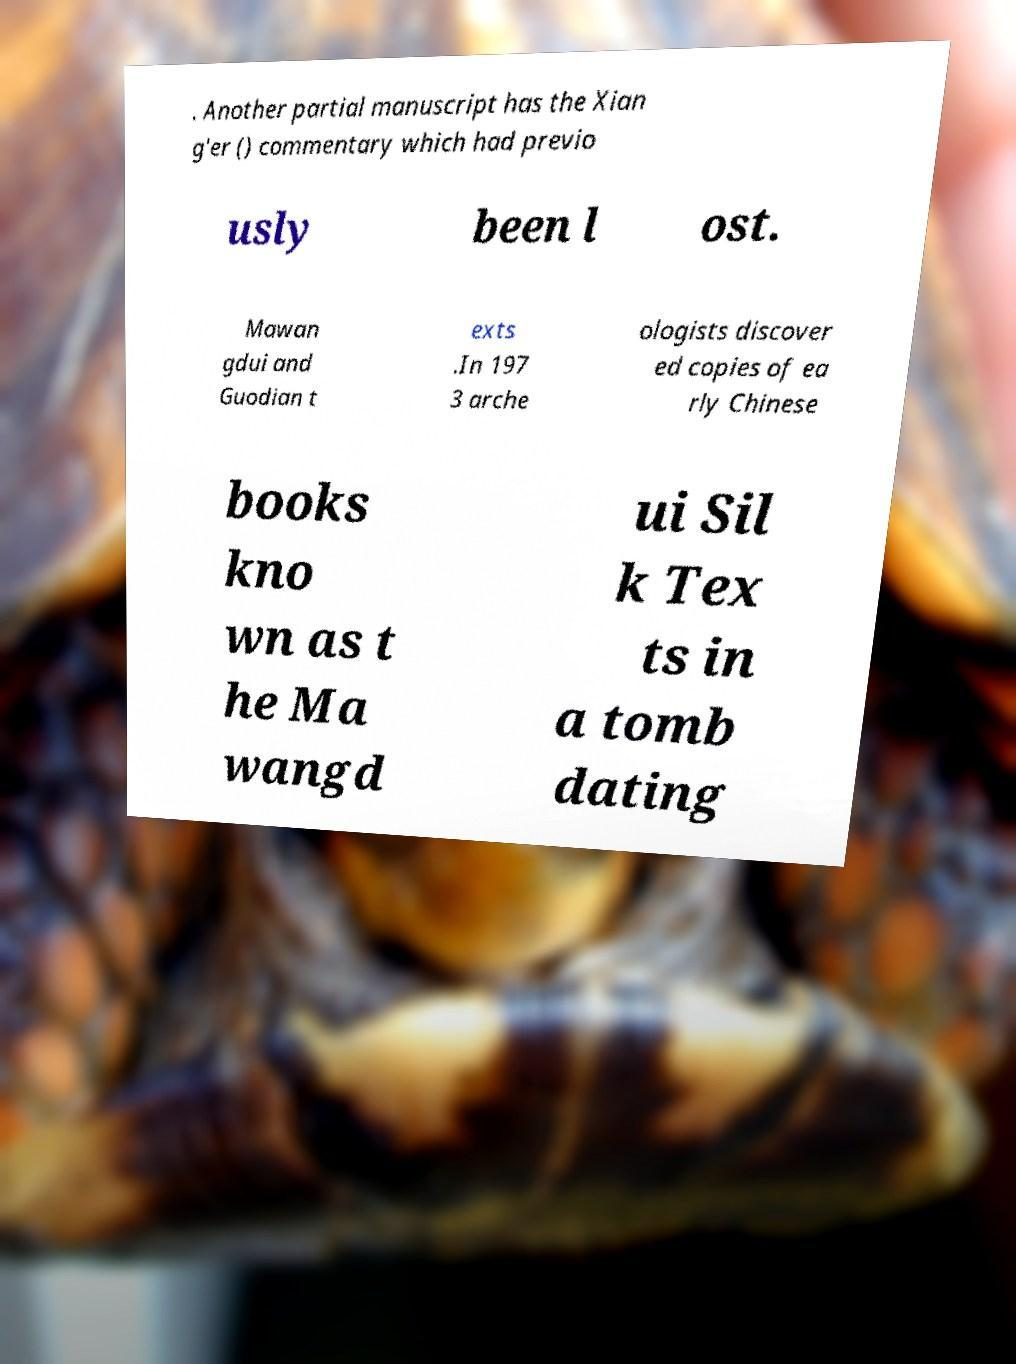For documentation purposes, I need the text within this image transcribed. Could you provide that? . Another partial manuscript has the Xian g'er () commentary which had previo usly been l ost. Mawan gdui and Guodian t exts .In 197 3 arche ologists discover ed copies of ea rly Chinese books kno wn as t he Ma wangd ui Sil k Tex ts in a tomb dating 